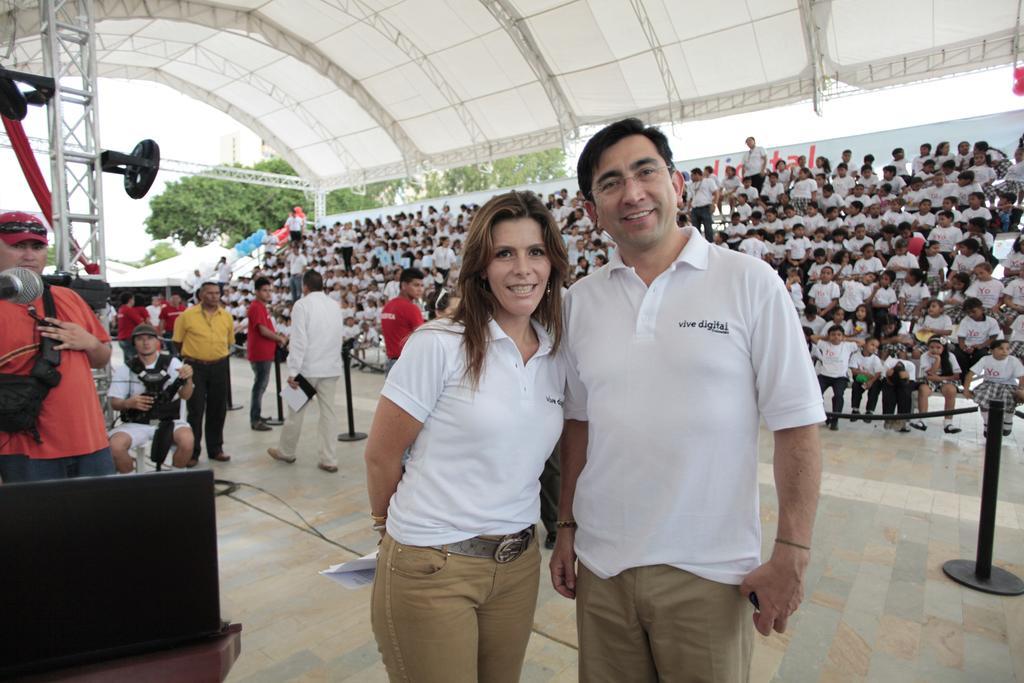Describe this image in one or two sentences. In this picture we can see two people smiling and at the back of them we can see a group of people sitting and some people are standing on the floor, mic, shelter, clothes, some objects and in the background we can see trees. 